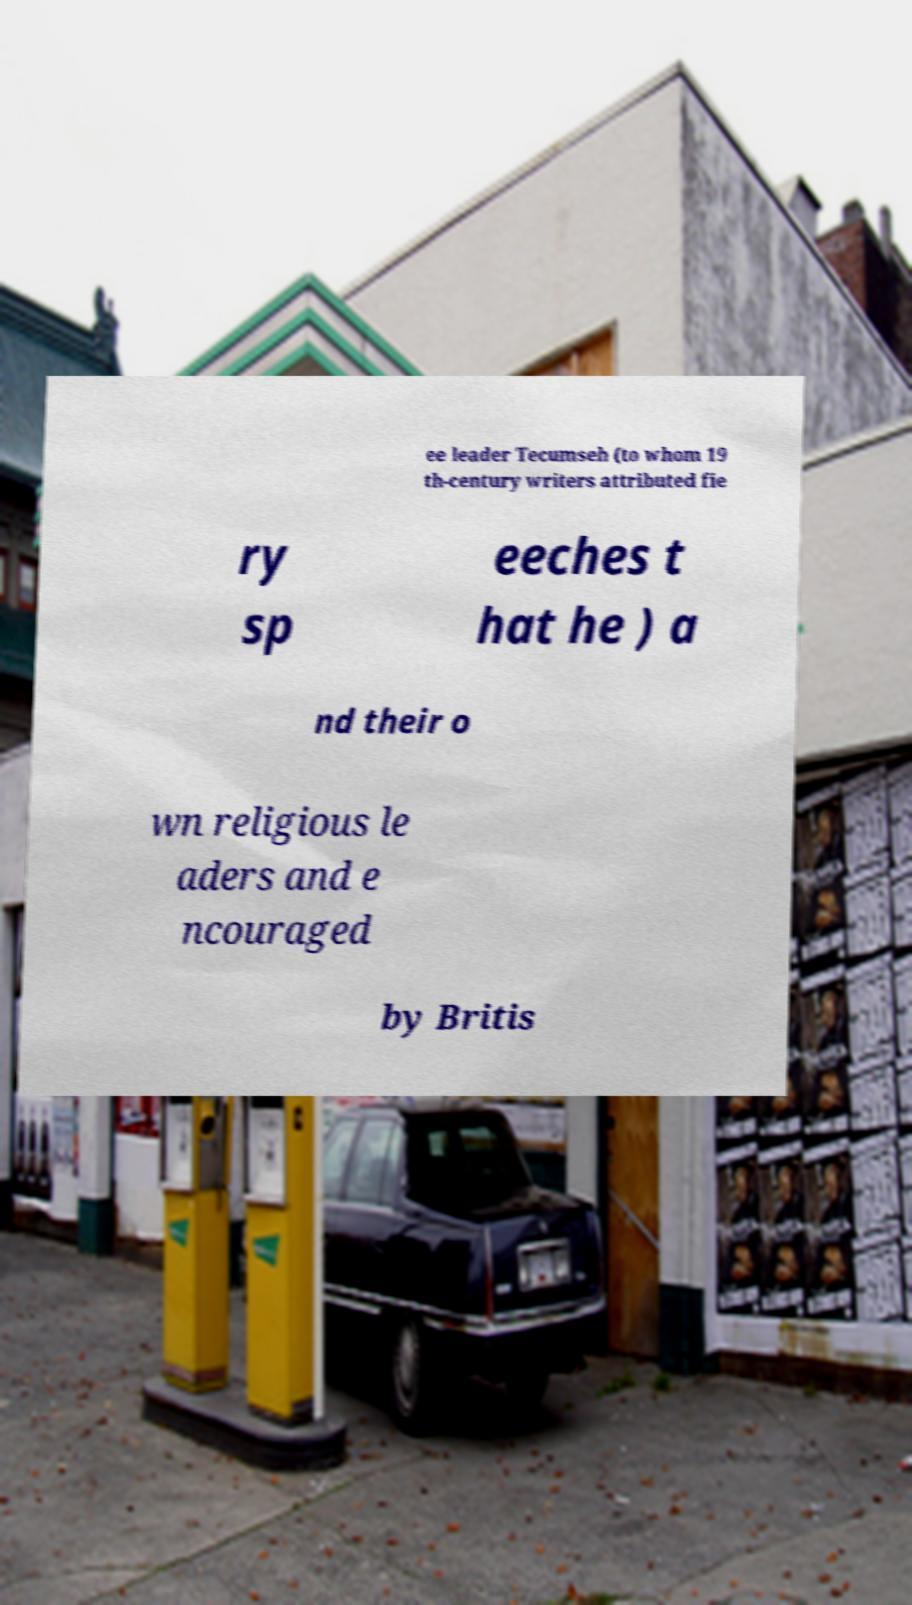I need the written content from this picture converted into text. Can you do that? ee leader Tecumseh (to whom 19 th-century writers attributed fie ry sp eeches t hat he ) a nd their o wn religious le aders and e ncouraged by Britis 